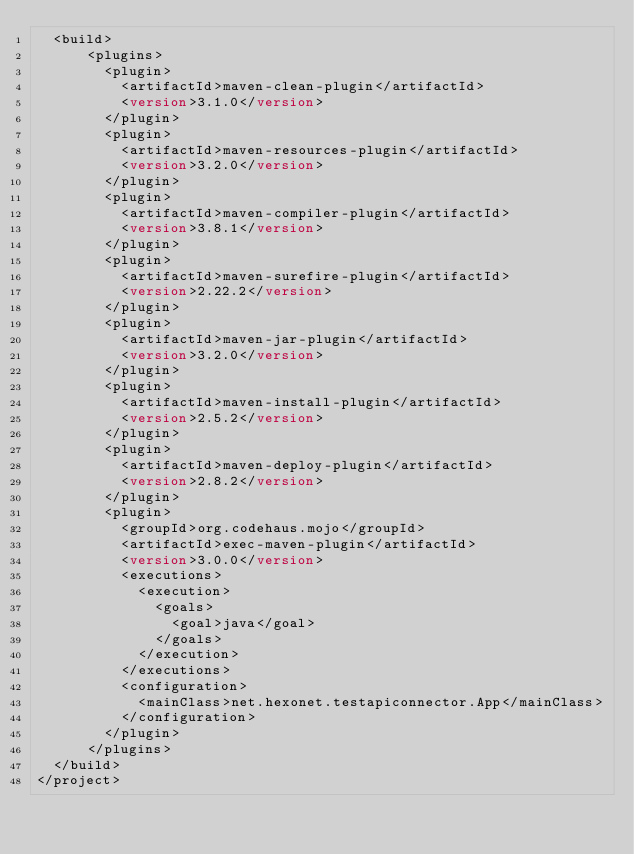Convert code to text. <code><loc_0><loc_0><loc_500><loc_500><_XML_>  <build>
      <plugins>
        <plugin>
          <artifactId>maven-clean-plugin</artifactId>
          <version>3.1.0</version>
        </plugin>
        <plugin>
          <artifactId>maven-resources-plugin</artifactId>
          <version>3.2.0</version>
        </plugin>
        <plugin>
          <artifactId>maven-compiler-plugin</artifactId>
          <version>3.8.1</version>
        </plugin>
        <plugin>
          <artifactId>maven-surefire-plugin</artifactId>
          <version>2.22.2</version>
        </plugin>
        <plugin>
          <artifactId>maven-jar-plugin</artifactId>
          <version>3.2.0</version>
        </plugin>
        <plugin>
          <artifactId>maven-install-plugin</artifactId>
          <version>2.5.2</version>
        </plugin>
        <plugin>
          <artifactId>maven-deploy-plugin</artifactId>
          <version>2.8.2</version>
        </plugin>
        <plugin>
          <groupId>org.codehaus.mojo</groupId>
          <artifactId>exec-maven-plugin</artifactId>
          <version>3.0.0</version>
          <executions>
            <execution>
              <goals>
                <goal>java</goal>
              </goals>
            </execution>
          </executions>
          <configuration>
            <mainClass>net.hexonet.testapiconnector.App</mainClass>
          </configuration>
        </plugin>
      </plugins>
  </build>
</project>
</code> 